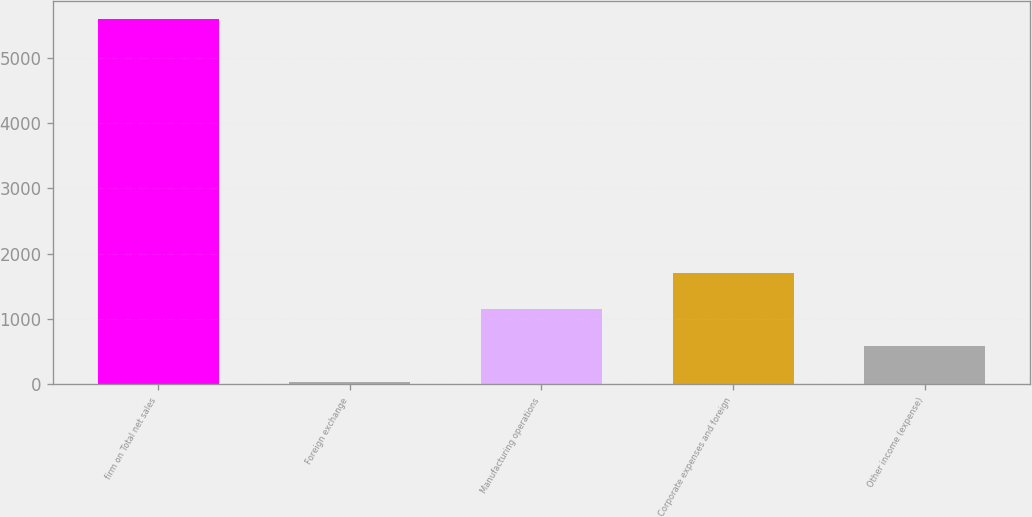<chart> <loc_0><loc_0><loc_500><loc_500><bar_chart><fcel>firm on Total net sales<fcel>Foreign exchange<fcel>Manufacturing operations<fcel>Corporate expenses and foreign<fcel>Other income (expense)<nl><fcel>5585<fcel>39<fcel>1148.2<fcel>1702.8<fcel>593.6<nl></chart> 